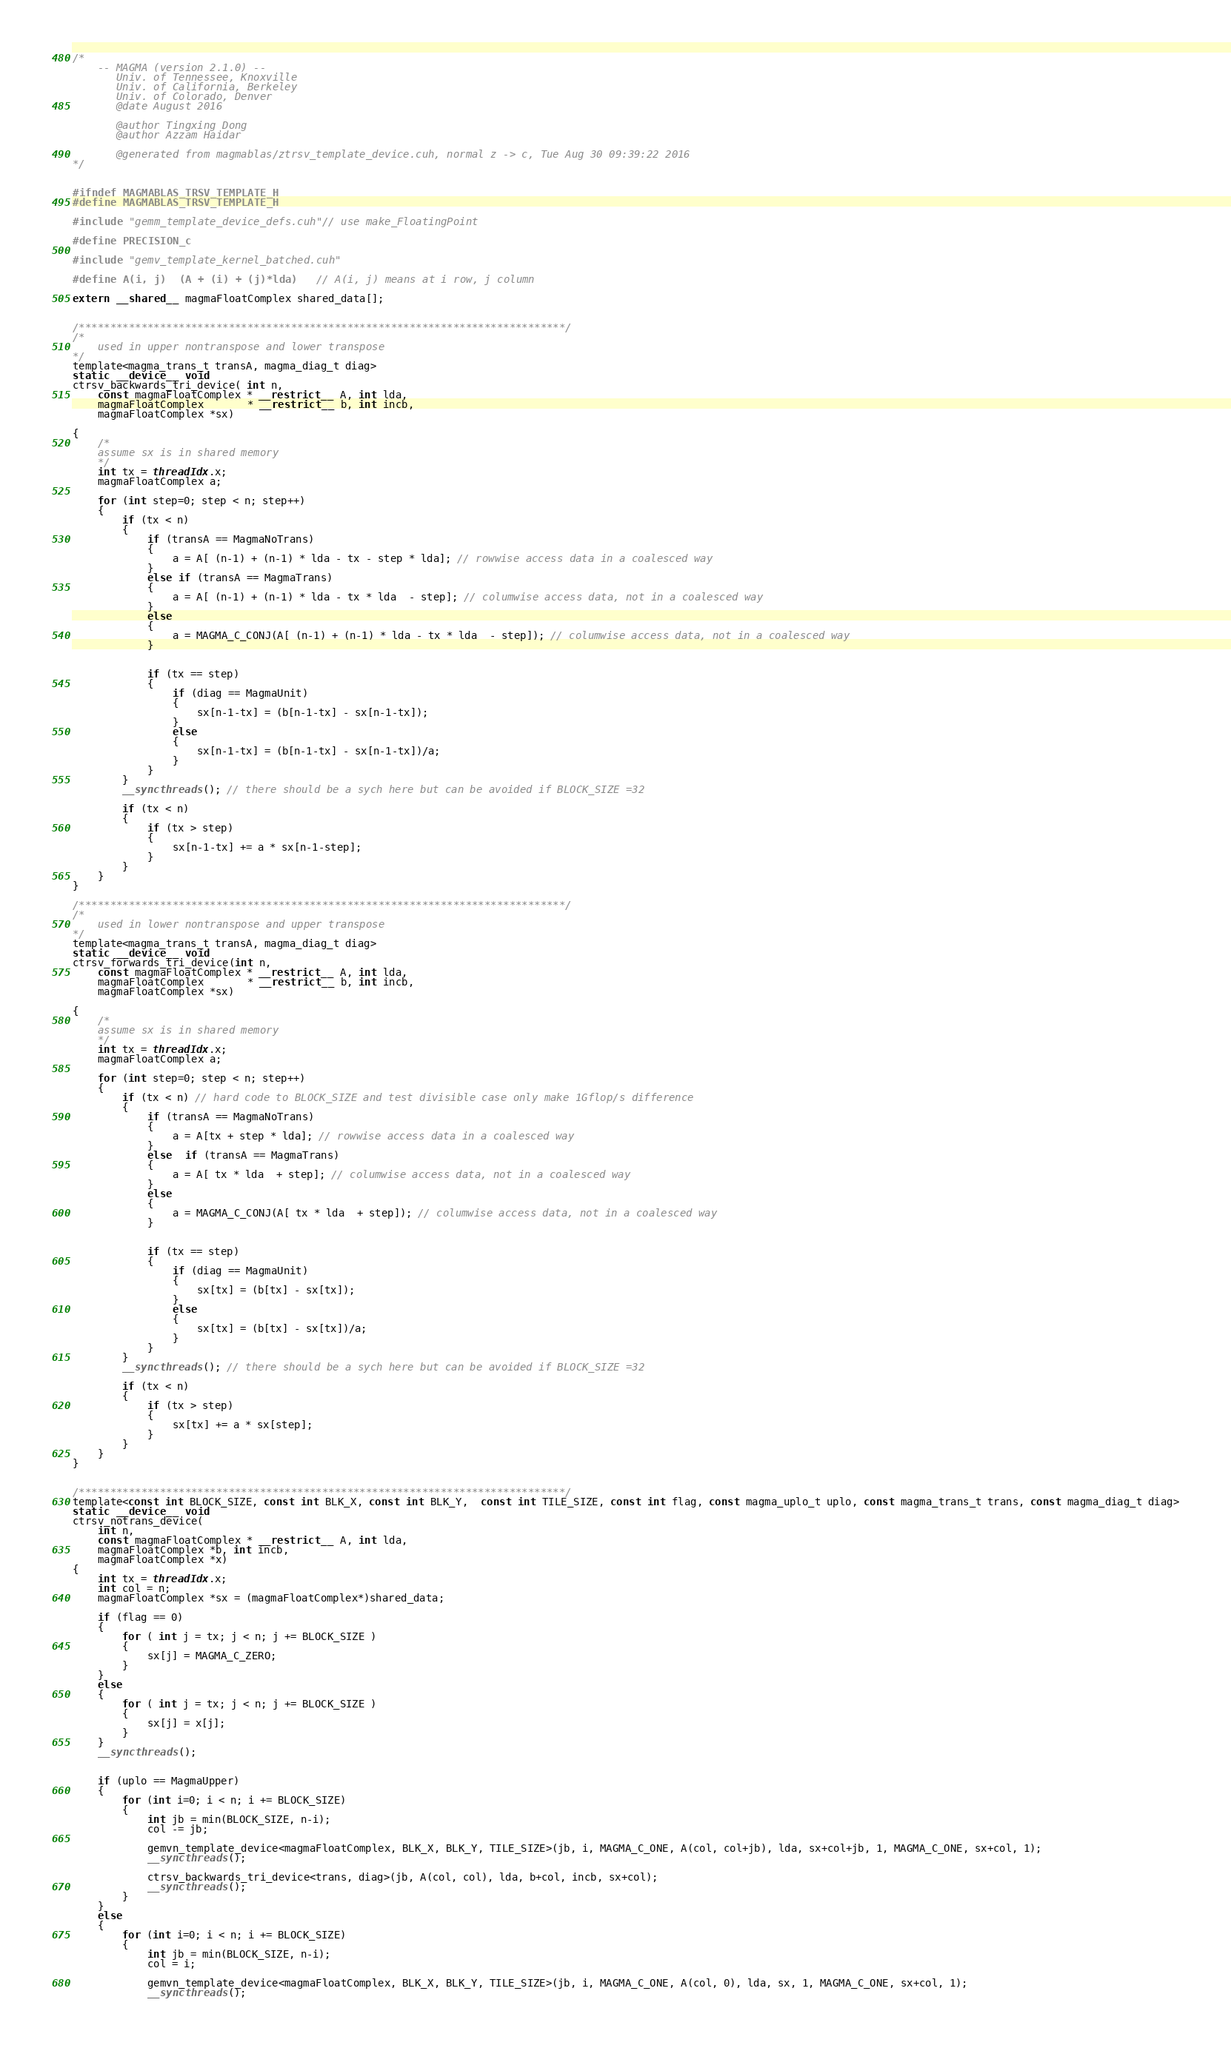Convert code to text. <code><loc_0><loc_0><loc_500><loc_500><_Cuda_>/*
    -- MAGMA (version 2.1.0) --
       Univ. of Tennessee, Knoxville
       Univ. of California, Berkeley
       Univ. of Colorado, Denver
       @date August 2016

       @author Tingxing Dong
       @author Azzam Haidar

       @generated from magmablas/ztrsv_template_device.cuh, normal z -> c, Tue Aug 30 09:39:22 2016
*/


#ifndef MAGMABLAS_TRSV_TEMPLATE_H
#define MAGMABLAS_TRSV_TEMPLATE_H

#include "gemm_template_device_defs.cuh"// use make_FloatingPoint

#define PRECISION_c

#include "gemv_template_kernel_batched.cuh"

#define A(i, j)  (A + (i) + (j)*lda)   // A(i, j) means at i row, j column

extern __shared__ magmaFloatComplex shared_data[];


/******************************************************************************/
/*
    used in upper nontranspose and lower transpose
*/
template<magma_trans_t transA, magma_diag_t diag>
static __device__ void
ctrsv_backwards_tri_device( int n,
    const magmaFloatComplex * __restrict__ A, int lda,
    magmaFloatComplex       * __restrict__ b, int incb,
    magmaFloatComplex *sx)

{
    /*
    assume sx is in shared memory
    */
    int tx = threadIdx.x;
    magmaFloatComplex a;

    for (int step=0; step < n; step++)
    {
        if (tx < n)
        {
            if (transA == MagmaNoTrans)
            {
                a = A[ (n-1) + (n-1) * lda - tx - step * lda]; // rowwise access data in a coalesced way
            }
            else if (transA == MagmaTrans)
            {
                a = A[ (n-1) + (n-1) * lda - tx * lda  - step]; // columwise access data, not in a coalesced way
            }
            else
            {
                a = MAGMA_C_CONJ(A[ (n-1) + (n-1) * lda - tx * lda  - step]); // columwise access data, not in a coalesced way
            }


            if (tx == step)
            {
                if (diag == MagmaUnit)
                {
                    sx[n-1-tx] = (b[n-1-tx] - sx[n-1-tx]);
                }
                else
                {
                    sx[n-1-tx] = (b[n-1-tx] - sx[n-1-tx])/a;
                }
            }
        }
        __syncthreads(); // there should be a sych here but can be avoided if BLOCK_SIZE =32

        if (tx < n)
        {
            if (tx > step)
            {
                sx[n-1-tx] += a * sx[n-1-step];
            }
        }
    }
}

/******************************************************************************/
/*
    used in lower nontranspose and upper transpose
*/
template<magma_trans_t transA, magma_diag_t diag>
static __device__ void
ctrsv_forwards_tri_device(int n,
    const magmaFloatComplex * __restrict__ A, int lda,
    magmaFloatComplex       * __restrict__ b, int incb,
    magmaFloatComplex *sx)

{
    /*
    assume sx is in shared memory
    */
    int tx = threadIdx.x;
    magmaFloatComplex a;

    for (int step=0; step < n; step++)
    {
        if (tx < n) // hard code to BLOCK_SIZE and test divisible case only make 1Gflop/s difference
        {
            if (transA == MagmaNoTrans)
            {
                a = A[tx + step * lda]; // rowwise access data in a coalesced way
            }
            else  if (transA == MagmaTrans)
            {
                a = A[ tx * lda  + step]; // columwise access data, not in a coalesced way
            }
            else
            {
                a = MAGMA_C_CONJ(A[ tx * lda  + step]); // columwise access data, not in a coalesced way
            }


            if (tx == step)
            {
                if (diag == MagmaUnit)
                {
                    sx[tx] = (b[tx] - sx[tx]);
                }
                else
                {
                    sx[tx] = (b[tx] - sx[tx])/a;
                }
            }
        }
        __syncthreads(); // there should be a sych here but can be avoided if BLOCK_SIZE =32

        if (tx < n)
        {
            if (tx > step)
            {
                sx[tx] += a * sx[step];
            }
        }
    }
}


/******************************************************************************/
template<const int BLOCK_SIZE, const int BLK_X, const int BLK_Y,  const int TILE_SIZE, const int flag, const magma_uplo_t uplo, const magma_trans_t trans, const magma_diag_t diag>
static __device__ void
ctrsv_notrans_device(
    int n,
    const magmaFloatComplex * __restrict__ A, int lda,
    magmaFloatComplex *b, int incb,
    magmaFloatComplex *x)
{
    int tx = threadIdx.x;
    int col = n;
    magmaFloatComplex *sx = (magmaFloatComplex*)shared_data;

    if (flag == 0)
    {
        for ( int j = tx; j < n; j += BLOCK_SIZE )
        {
            sx[j] = MAGMA_C_ZERO;
        }
    }
    else
    {
        for ( int j = tx; j < n; j += BLOCK_SIZE )
        {
            sx[j] = x[j];
        }
    }
    __syncthreads();


    if (uplo == MagmaUpper)
    {
        for (int i=0; i < n; i += BLOCK_SIZE)
        {
            int jb = min(BLOCK_SIZE, n-i);
            col -= jb;

            gemvn_template_device<magmaFloatComplex, BLK_X, BLK_Y, TILE_SIZE>(jb, i, MAGMA_C_ONE, A(col, col+jb), lda, sx+col+jb, 1, MAGMA_C_ONE, sx+col, 1);
            __syncthreads();

            ctrsv_backwards_tri_device<trans, diag>(jb, A(col, col), lda, b+col, incb, sx+col);
            __syncthreads();
        }
    }
    else
    {
        for (int i=0; i < n; i += BLOCK_SIZE)
        {
            int jb = min(BLOCK_SIZE, n-i);
            col = i;

            gemvn_template_device<magmaFloatComplex, BLK_X, BLK_Y, TILE_SIZE>(jb, i, MAGMA_C_ONE, A(col, 0), lda, sx, 1, MAGMA_C_ONE, sx+col, 1);
            __syncthreads();
</code> 